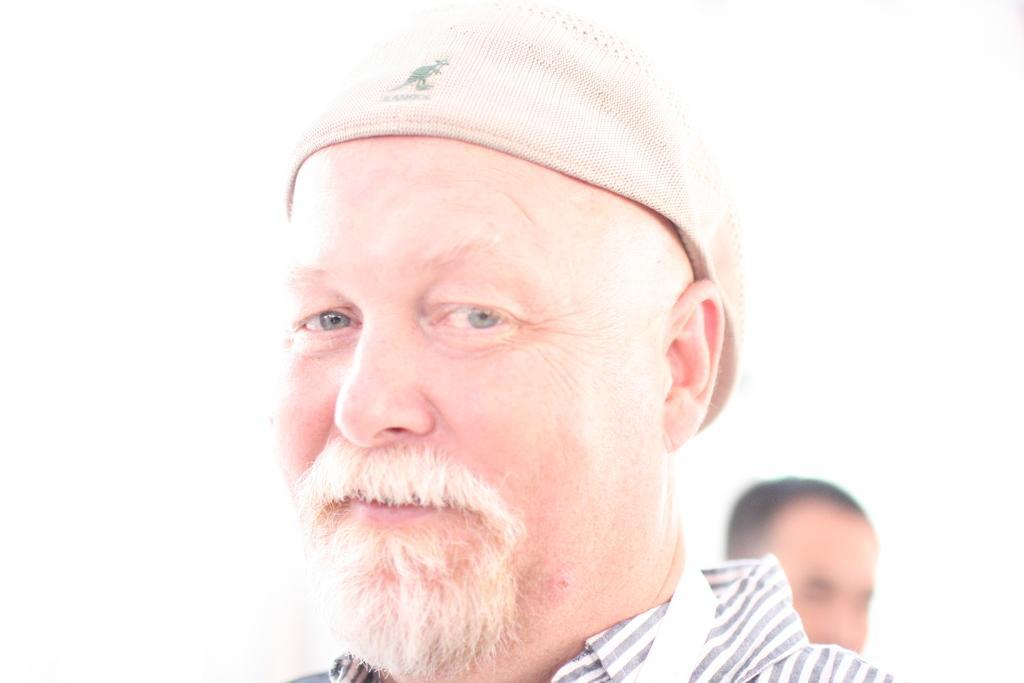In one or two sentences, can you explain what this image depicts? In the middle of the image, there is a person in a shirt, wearing a cap and smiling. In the background, there is another person. And the background is white in color. 